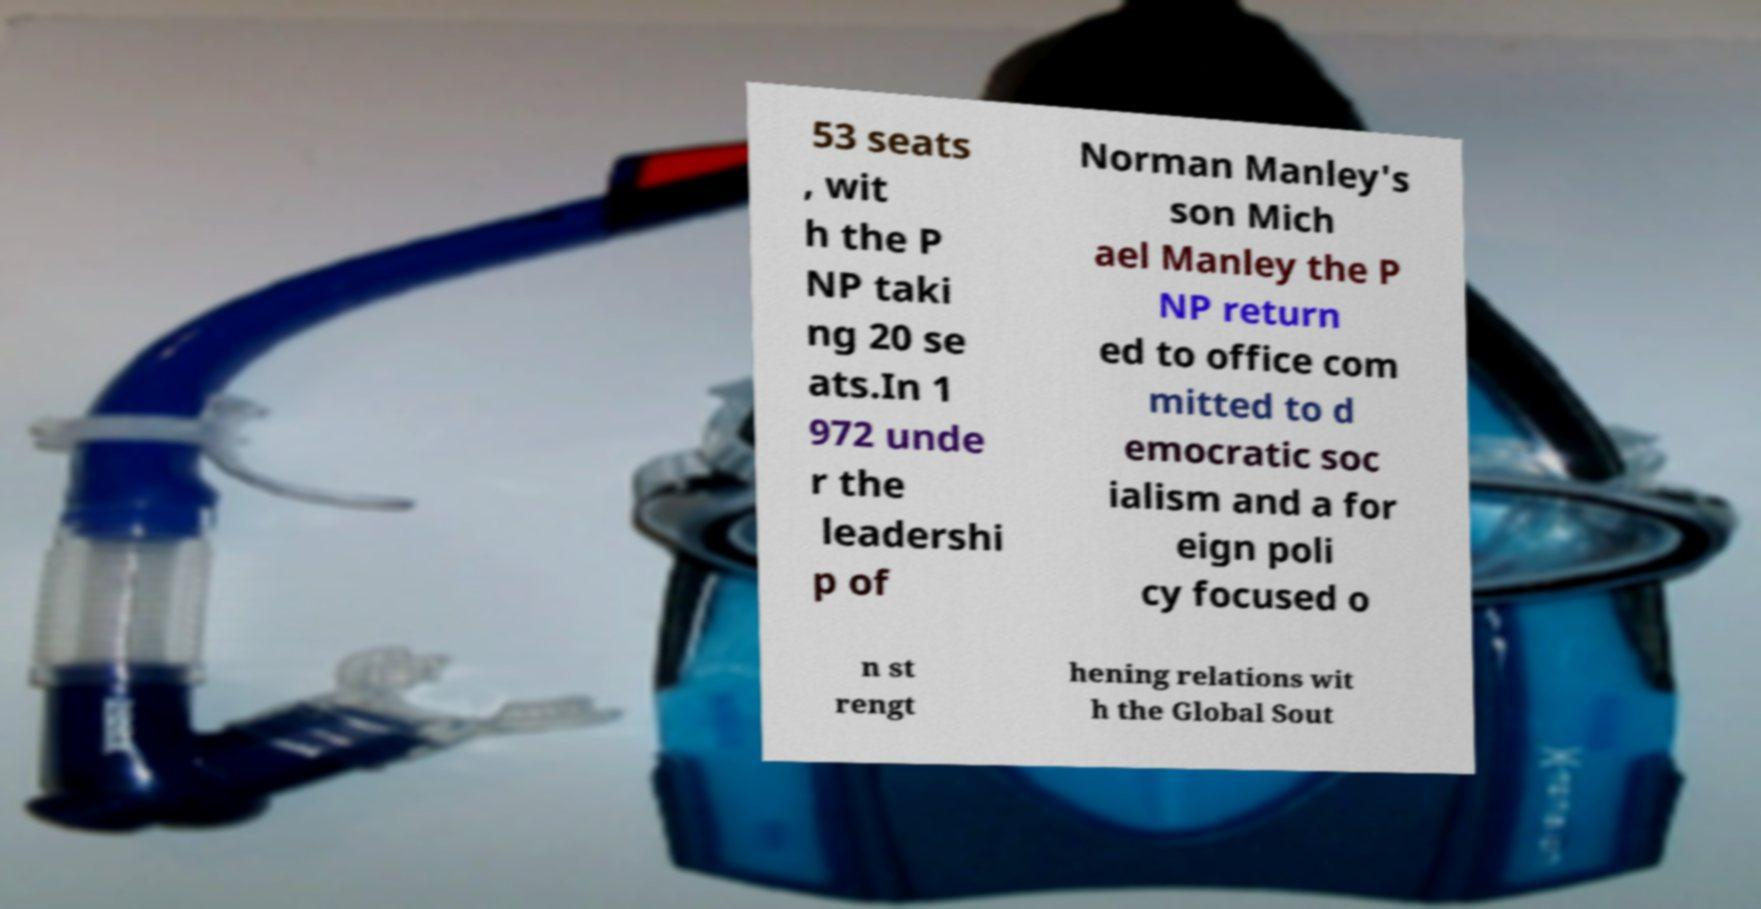Please read and relay the text visible in this image. What does it say? 53 seats , wit h the P NP taki ng 20 se ats.In 1 972 unde r the leadershi p of Norman Manley's son Mich ael Manley the P NP return ed to office com mitted to d emocratic soc ialism and a for eign poli cy focused o n st rengt hening relations wit h the Global Sout 